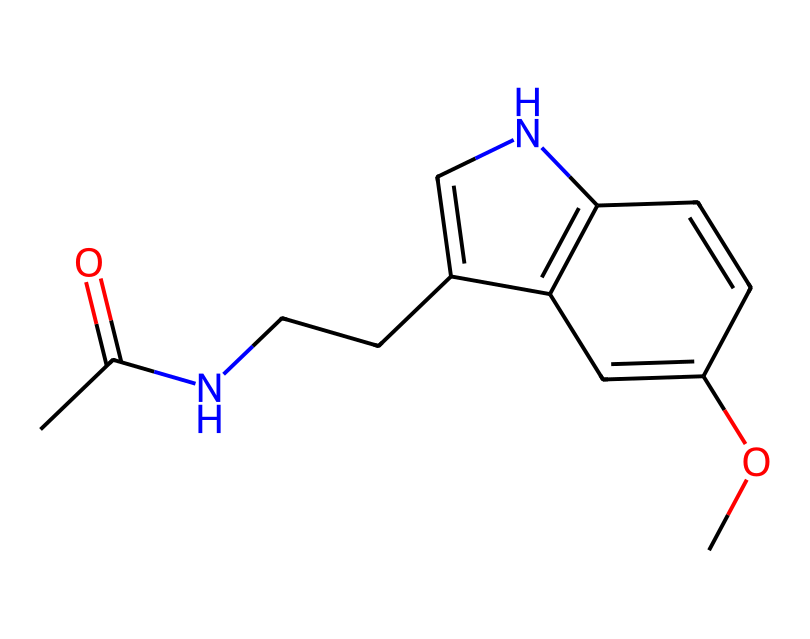How many nitrogen atoms are present in this chemical structure? There are two nitrogen atoms in the structure, indicated by the presence of 'N' in the SMILES representation.
Answer: two What is the main functional group present in melatonin? The SMILES includes an amide group denoted by the 'C(=O)N' portion, which is characteristic of melatonin.
Answer: amide How many rings are present in the structure of melatonin? The structure features two interconnected rings, which can be recognized through the 'C1' and 'C2' labels in the SMILES, indicating cyclic components.
Answer: two Does this chemical contain any methoxy groups? Yes, the presence of 'OC' in the SMILES shows that a methoxy group ('-OCH3') is part of the structure.
Answer: yes What kind of chemical is melatonin primarily classified as? Melatonin is primarily classified as an indoleamine, as indicated by the fused indole rings present in its structure.
Answer: indoleamine What is the key structural feature that allows melatonin to interact with receptors in the brain? The presence of the methoxy group and the cyclic structure allows melatonin to effectively fit and interact with melatonin receptors in the brain.
Answer: cyclic structure How does the acetyl group influence the chemical stability of melatonin? The acetyl group, represented by 'CC(=O)', contributes to the stability of the molecule through resonance, allowing for better interaction with biological targets.
Answer: resonance stability 